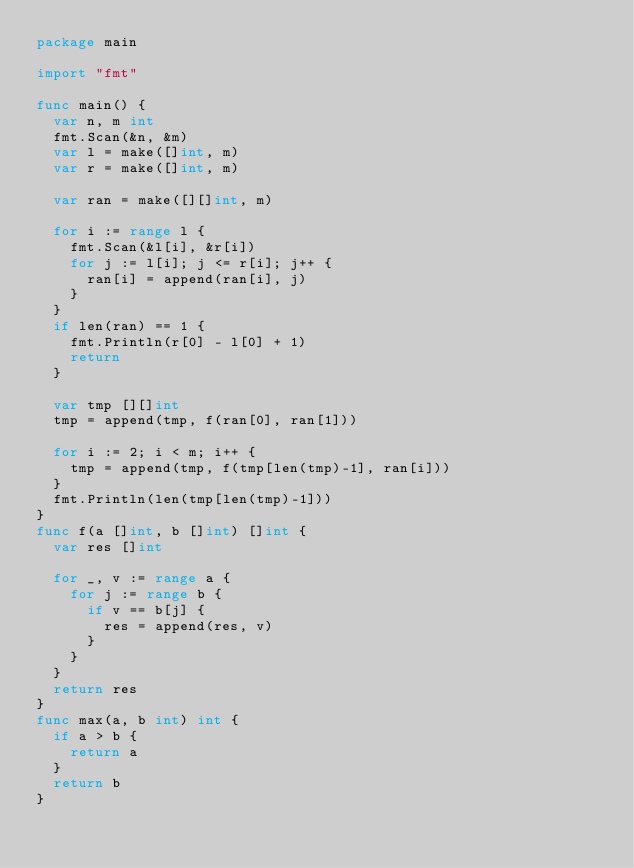<code> <loc_0><loc_0><loc_500><loc_500><_Go_>package main

import "fmt"

func main() {
	var n, m int
	fmt.Scan(&n, &m)
	var l = make([]int, m)
	var r = make([]int, m)

	var ran = make([][]int, m)

	for i := range l {
		fmt.Scan(&l[i], &r[i])
		for j := l[i]; j <= r[i]; j++ {
			ran[i] = append(ran[i], j)
		}
	}
	if len(ran) == 1 {
		fmt.Println(r[0] - l[0] + 1)
		return
	}

	var tmp [][]int
	tmp = append(tmp, f(ran[0], ran[1]))

	for i := 2; i < m; i++ {
		tmp = append(tmp, f(tmp[len(tmp)-1], ran[i]))
	}
	fmt.Println(len(tmp[len(tmp)-1]))
}
func f(a []int, b []int) []int {
	var res []int

	for _, v := range a {
		for j := range b {
			if v == b[j] {
				res = append(res, v)
			}
		}
	}
	return res
}
func max(a, b int) int {
	if a > b {
		return a
	}
	return b
}</code> 